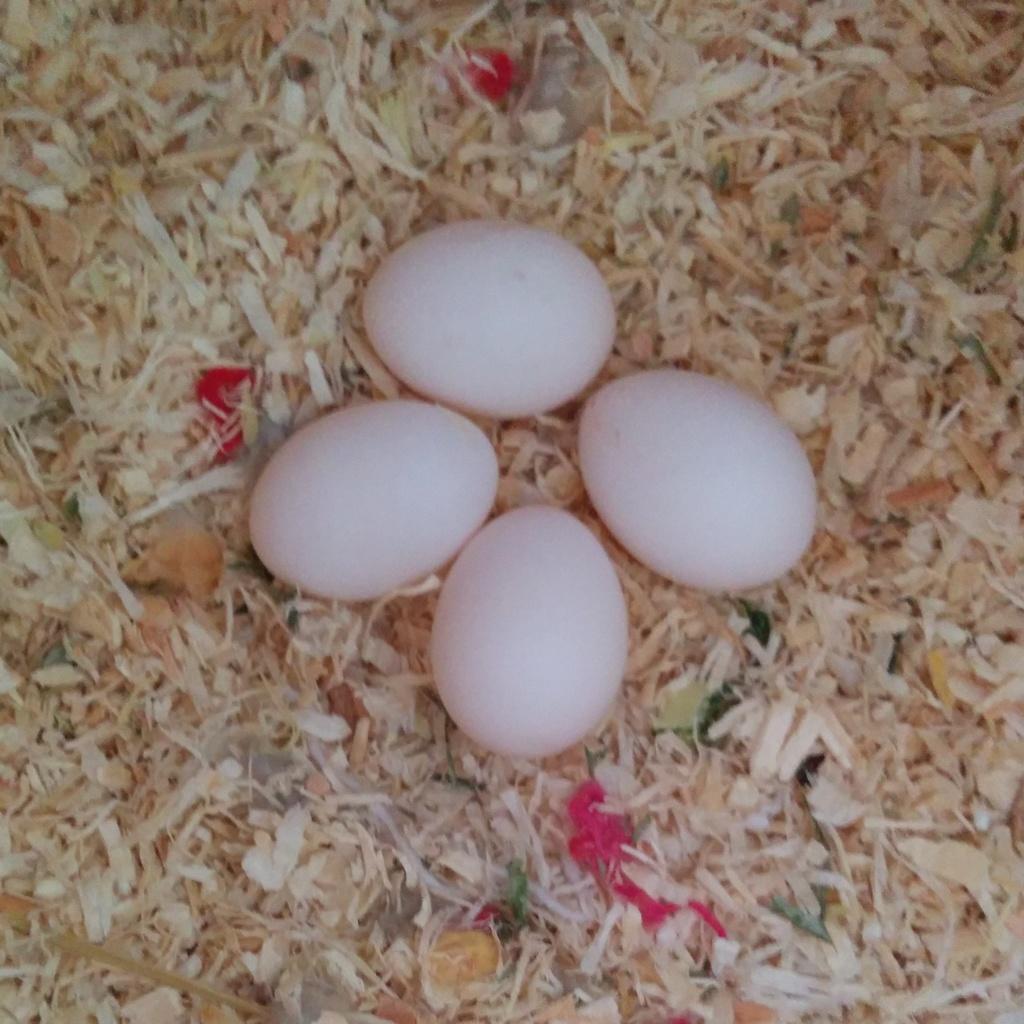Please provide a concise description of this image. In this image I see 4 eggs on the cream colored things. 